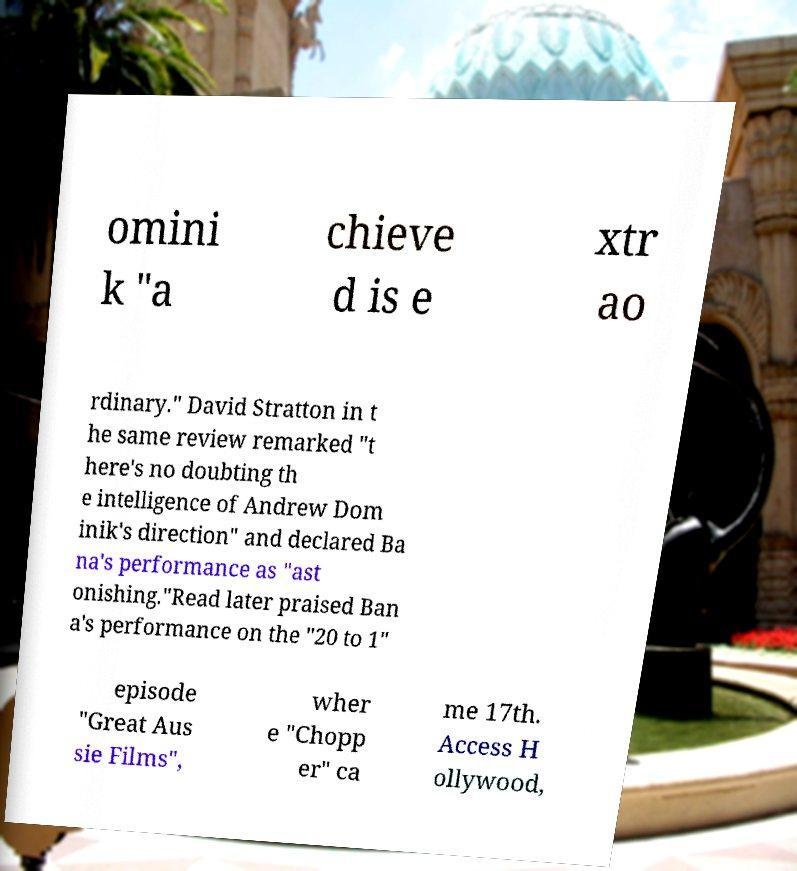Please read and relay the text visible in this image. What does it say? omini k "a chieve d is e xtr ao rdinary." David Stratton in t he same review remarked "t here's no doubting th e intelligence of Andrew Dom inik's direction" and declared Ba na's performance as "ast onishing."Read later praised Ban a's performance on the "20 to 1" episode "Great Aus sie Films", wher e "Chopp er" ca me 17th. Access H ollywood, 